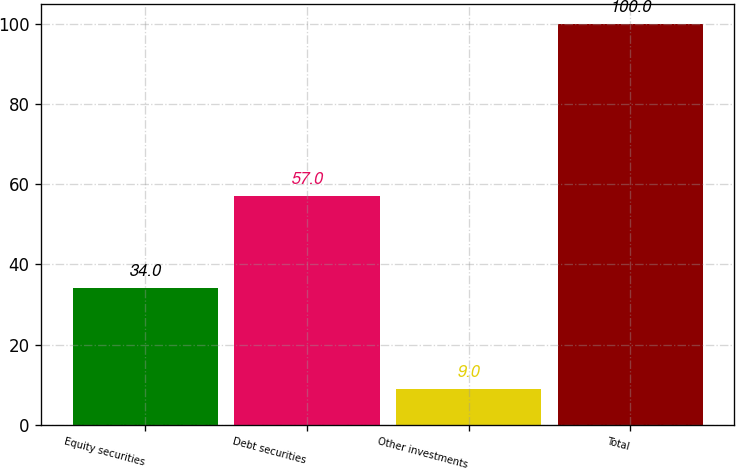Convert chart. <chart><loc_0><loc_0><loc_500><loc_500><bar_chart><fcel>Equity securities<fcel>Debt securities<fcel>Other investments<fcel>Total<nl><fcel>34<fcel>57<fcel>9<fcel>100<nl></chart> 